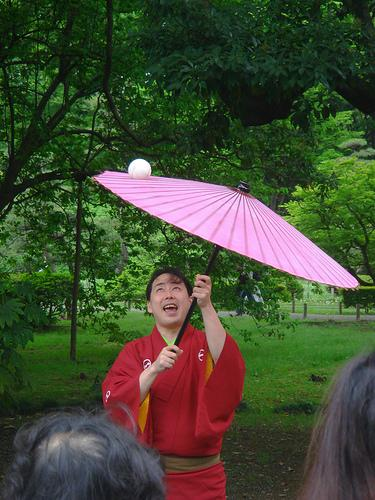Why is the ball on the parasol? trick 